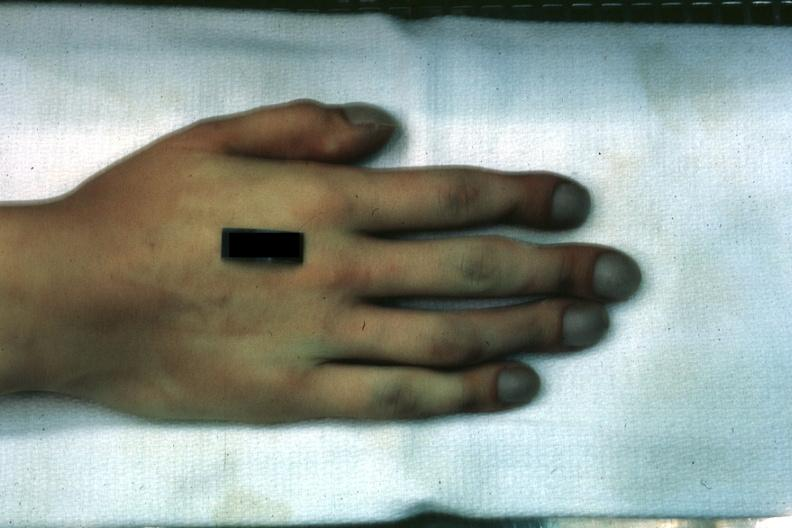what is present?
Answer the question using a single word or phrase. Pulmonary osteoarthropathy 